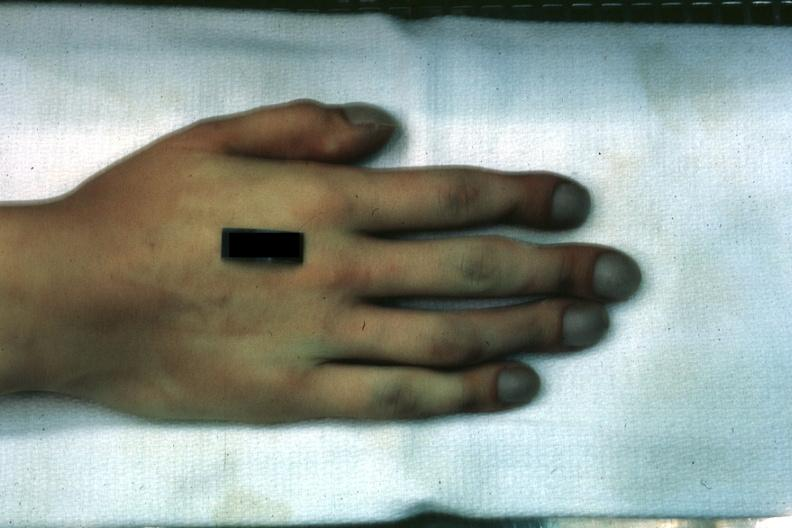what is present?
Answer the question using a single word or phrase. Pulmonary osteoarthropathy 